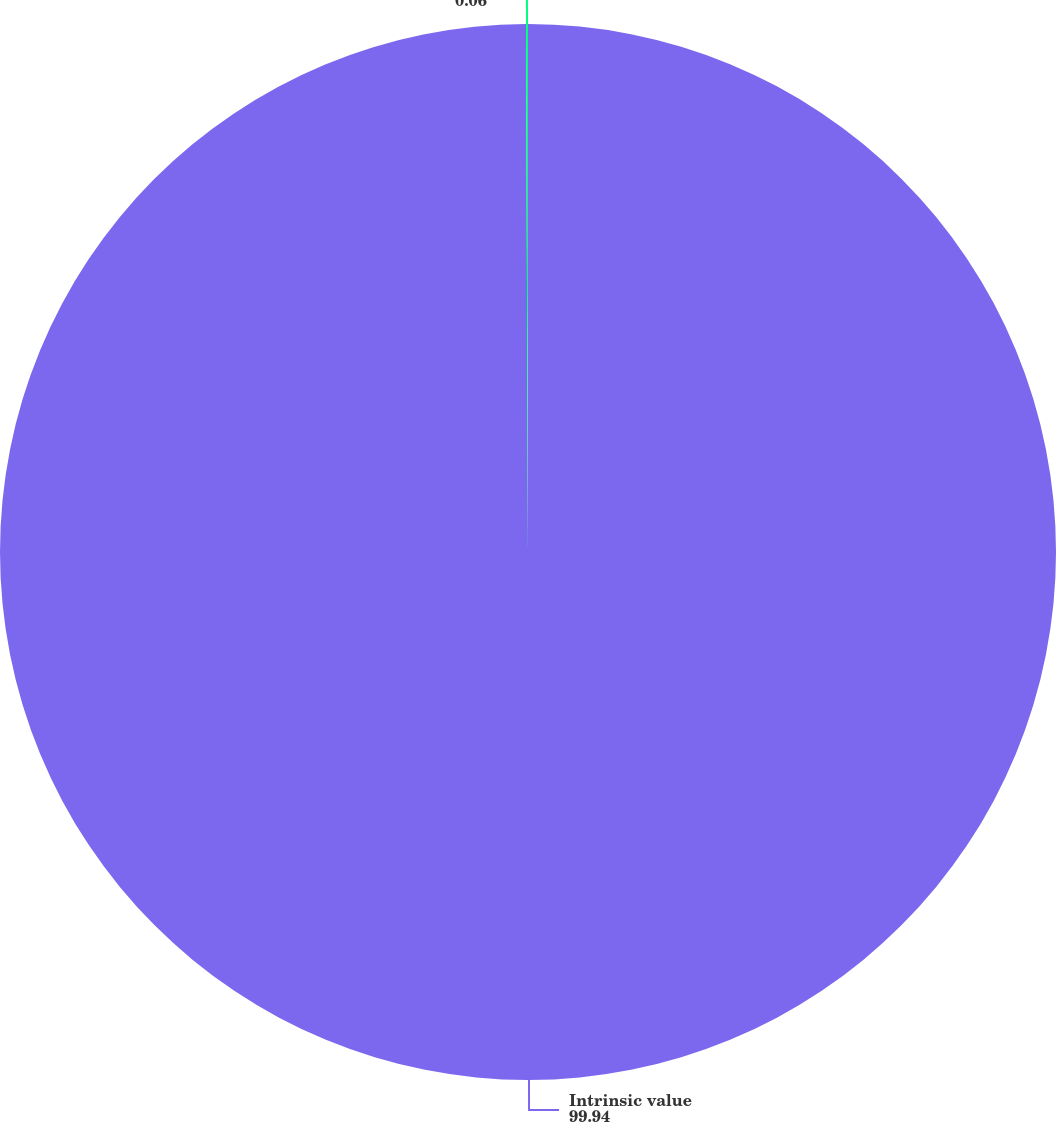Convert chart to OTSL. <chart><loc_0><loc_0><loc_500><loc_500><pie_chart><fcel>Intrinsic value<fcel>Average exercise price per<nl><fcel>99.94%<fcel>0.06%<nl></chart> 